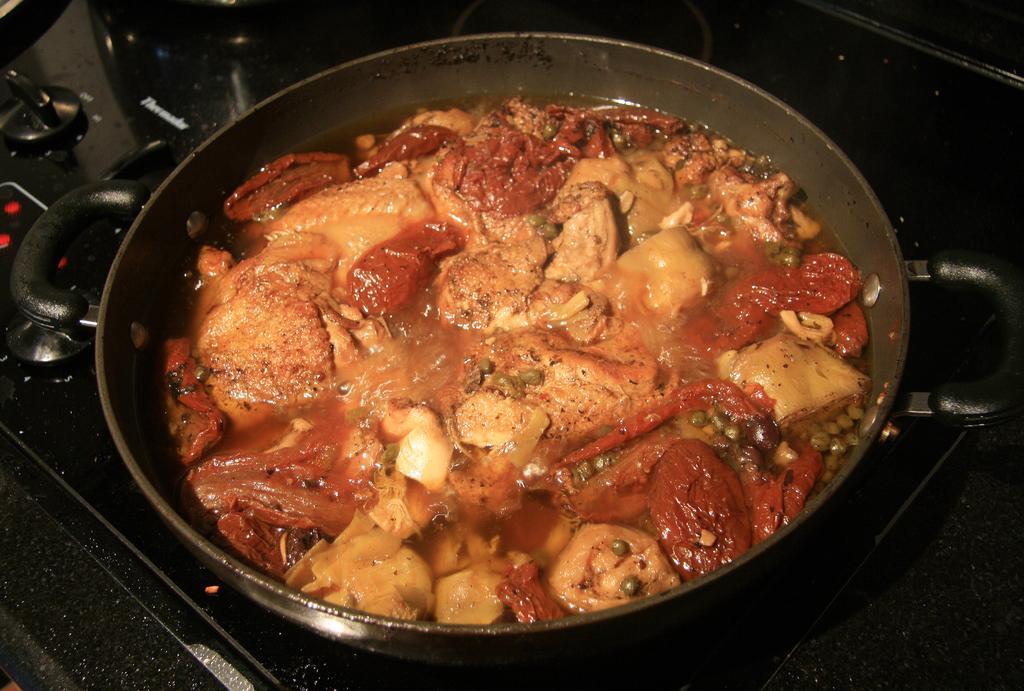In one or two sentences, can you explain what this image depicts? In this image, we can see some food item in a bowl is placed on the gas stove. 